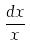Convert formula to latex. <formula><loc_0><loc_0><loc_500><loc_500>\frac { d x } { x }</formula> 